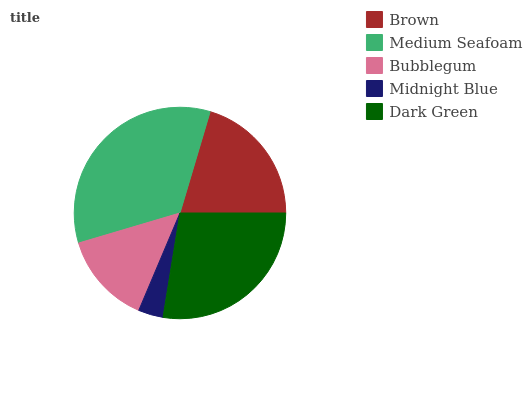Is Midnight Blue the minimum?
Answer yes or no. Yes. Is Medium Seafoam the maximum?
Answer yes or no. Yes. Is Bubblegum the minimum?
Answer yes or no. No. Is Bubblegum the maximum?
Answer yes or no. No. Is Medium Seafoam greater than Bubblegum?
Answer yes or no. Yes. Is Bubblegum less than Medium Seafoam?
Answer yes or no. Yes. Is Bubblegum greater than Medium Seafoam?
Answer yes or no. No. Is Medium Seafoam less than Bubblegum?
Answer yes or no. No. Is Brown the high median?
Answer yes or no. Yes. Is Brown the low median?
Answer yes or no. Yes. Is Midnight Blue the high median?
Answer yes or no. No. Is Bubblegum the low median?
Answer yes or no. No. 